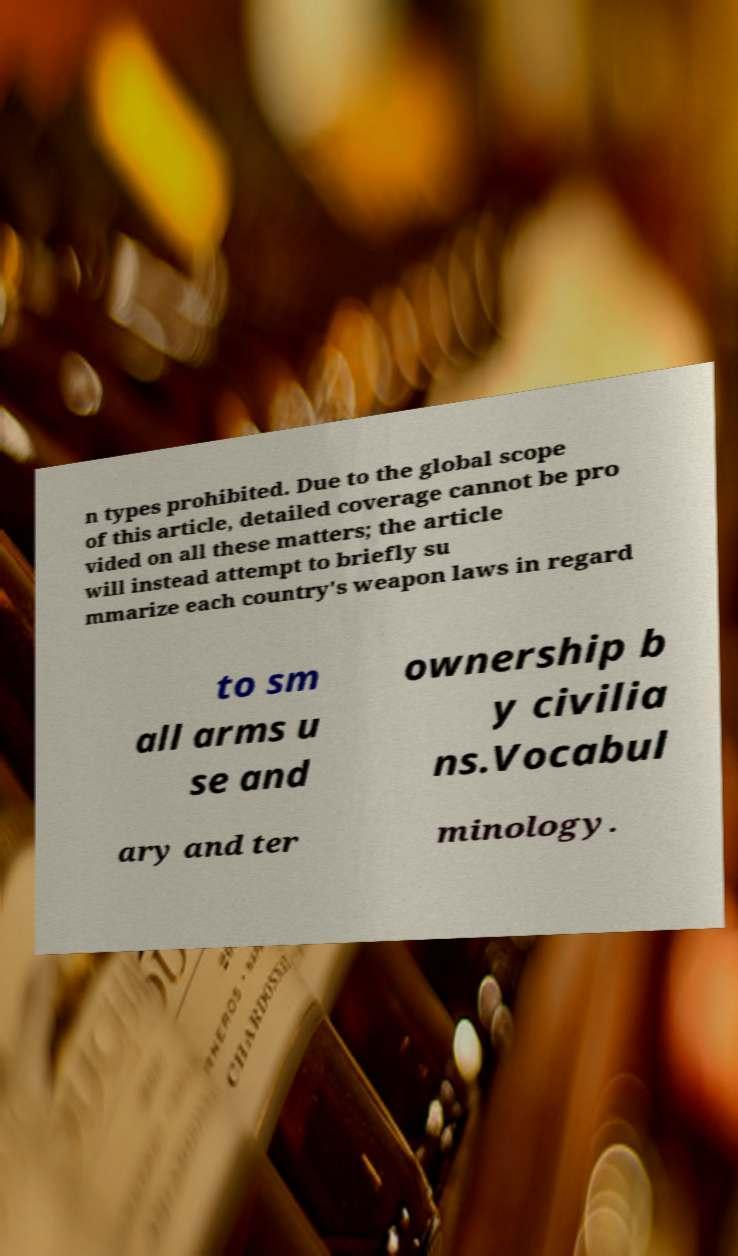I need the written content from this picture converted into text. Can you do that? n types prohibited. Due to the global scope of this article, detailed coverage cannot be pro vided on all these matters; the article will instead attempt to briefly su mmarize each country's weapon laws in regard to sm all arms u se and ownership b y civilia ns.Vocabul ary and ter minology. 